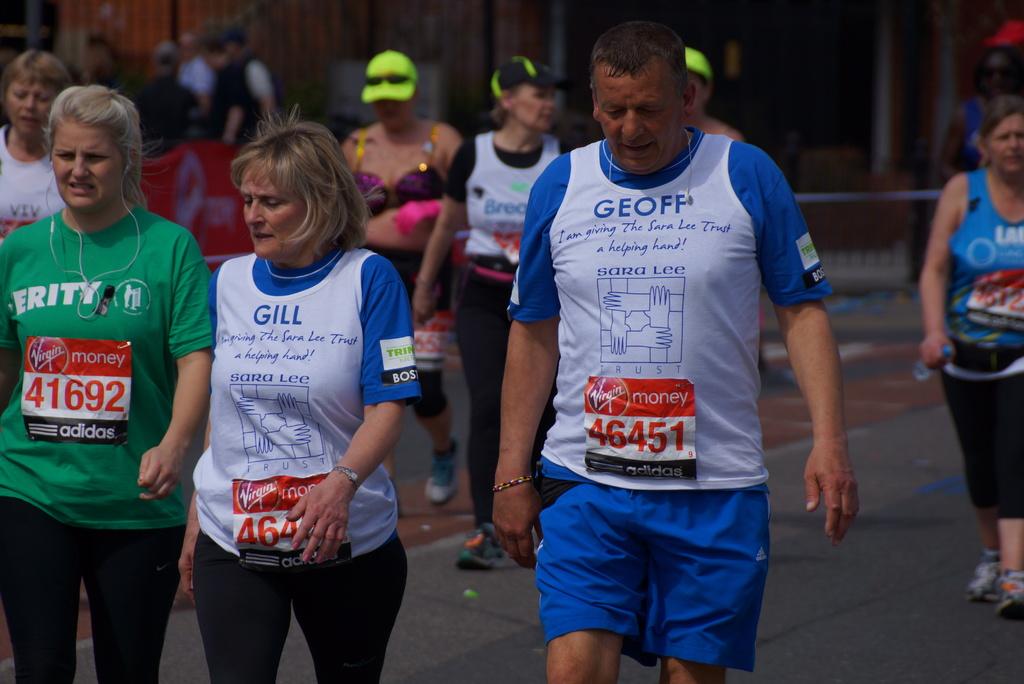What is the name of the gentleman in the front?
Ensure brevity in your answer.  Geoff. What shoe brand sponsors this event?
Provide a short and direct response. Adidas. 